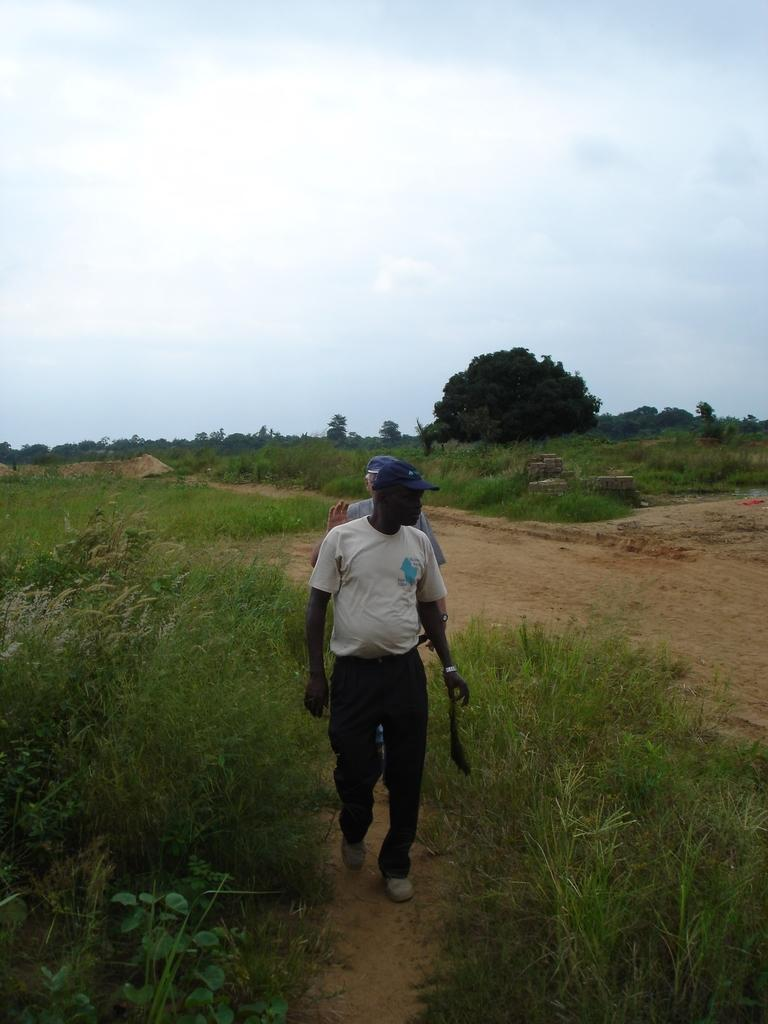How many people are in the image? There are two people in the image. Where are the people located in the image? The people are on a path in the image. What type of vegetation can be seen in the image? There is grass, plants, and trees in the image. What else is present in the image besides the people and vegetation? There are other objects in the image. What is visible in the sky in the image? The sky is visible in the image, and it contains clouds. What type of bait is being used by the creature in the image? There is no creature or bait present in the image. How much payment is required to enter the area in the image? There is no indication of payment or an entrance fee in the image. 